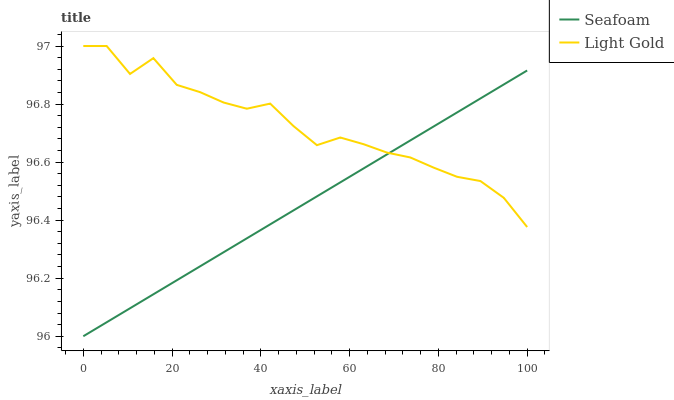Does Seafoam have the minimum area under the curve?
Answer yes or no. Yes. Does Light Gold have the maximum area under the curve?
Answer yes or no. Yes. Does Seafoam have the maximum area under the curve?
Answer yes or no. No. Is Seafoam the smoothest?
Answer yes or no. Yes. Is Light Gold the roughest?
Answer yes or no. Yes. Is Seafoam the roughest?
Answer yes or no. No. Does Seafoam have the lowest value?
Answer yes or no. Yes. Does Light Gold have the highest value?
Answer yes or no. Yes. Does Seafoam have the highest value?
Answer yes or no. No. Does Seafoam intersect Light Gold?
Answer yes or no. Yes. Is Seafoam less than Light Gold?
Answer yes or no. No. Is Seafoam greater than Light Gold?
Answer yes or no. No. 